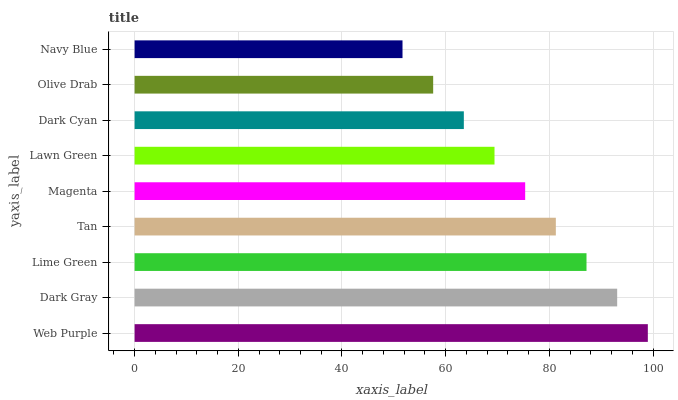Is Navy Blue the minimum?
Answer yes or no. Yes. Is Web Purple the maximum?
Answer yes or no. Yes. Is Dark Gray the minimum?
Answer yes or no. No. Is Dark Gray the maximum?
Answer yes or no. No. Is Web Purple greater than Dark Gray?
Answer yes or no. Yes. Is Dark Gray less than Web Purple?
Answer yes or no. Yes. Is Dark Gray greater than Web Purple?
Answer yes or no. No. Is Web Purple less than Dark Gray?
Answer yes or no. No. Is Magenta the high median?
Answer yes or no. Yes. Is Magenta the low median?
Answer yes or no. Yes. Is Tan the high median?
Answer yes or no. No. Is Lawn Green the low median?
Answer yes or no. No. 